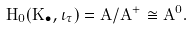<formula> <loc_0><loc_0><loc_500><loc_500>H _ { 0 } ( K _ { \bullet } , \iota _ { \tau } ) = A / A ^ { + } \cong A ^ { 0 } .</formula> 